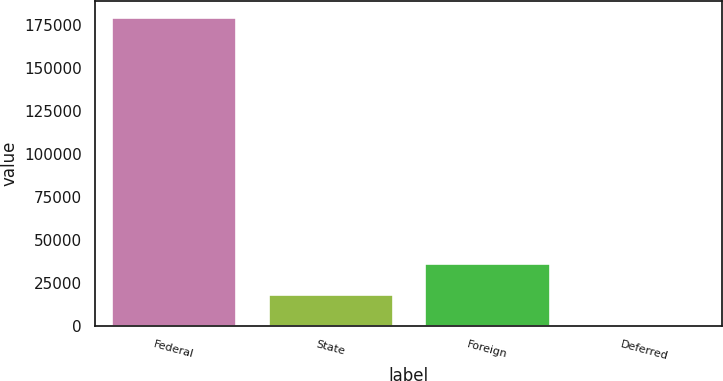Convert chart. <chart><loc_0><loc_0><loc_500><loc_500><bar_chart><fcel>Federal<fcel>State<fcel>Foreign<fcel>Deferred<nl><fcel>179884<fcel>18814.6<fcel>36711.2<fcel>918<nl></chart> 